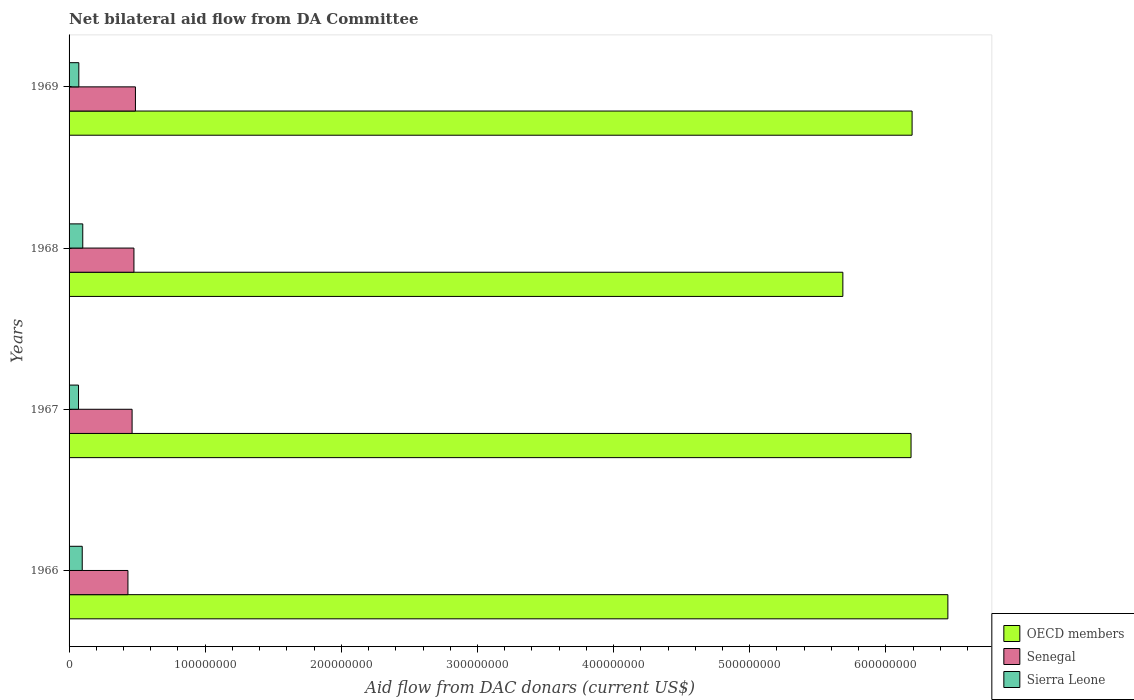Are the number of bars per tick equal to the number of legend labels?
Your answer should be compact. Yes. Are the number of bars on each tick of the Y-axis equal?
Provide a succinct answer. Yes. What is the label of the 3rd group of bars from the top?
Offer a very short reply. 1967. What is the aid flow in in OECD members in 1967?
Give a very brief answer. 6.18e+08. Across all years, what is the maximum aid flow in in Senegal?
Your answer should be compact. 4.88e+07. Across all years, what is the minimum aid flow in in Senegal?
Keep it short and to the point. 4.32e+07. In which year was the aid flow in in Sierra Leone maximum?
Offer a very short reply. 1968. In which year was the aid flow in in OECD members minimum?
Offer a terse response. 1968. What is the total aid flow in in Senegal in the graph?
Give a very brief answer. 1.86e+08. What is the difference between the aid flow in in OECD members in 1966 and that in 1967?
Your answer should be compact. 2.71e+07. What is the difference between the aid flow in in Senegal in 1969 and the aid flow in in OECD members in 1968?
Your answer should be very brief. -5.20e+08. What is the average aid flow in in Sierra Leone per year?
Provide a short and direct response. 8.46e+06. In the year 1968, what is the difference between the aid flow in in Sierra Leone and aid flow in in Senegal?
Keep it short and to the point. -3.76e+07. In how many years, is the aid flow in in OECD members greater than 440000000 US$?
Ensure brevity in your answer.  4. What is the ratio of the aid flow in in Senegal in 1967 to that in 1968?
Provide a succinct answer. 0.97. What is the difference between the highest and the second highest aid flow in in Sierra Leone?
Keep it short and to the point. 3.90e+05. What is the difference between the highest and the lowest aid flow in in Senegal?
Provide a succinct answer. 5.51e+06. Is the sum of the aid flow in in Senegal in 1967 and 1969 greater than the maximum aid flow in in Sierra Leone across all years?
Make the answer very short. Yes. What does the 3rd bar from the top in 1968 represents?
Ensure brevity in your answer.  OECD members. What does the 2nd bar from the bottom in 1967 represents?
Ensure brevity in your answer.  Senegal. Is it the case that in every year, the sum of the aid flow in in OECD members and aid flow in in Sierra Leone is greater than the aid flow in in Senegal?
Keep it short and to the point. Yes. How many bars are there?
Give a very brief answer. 12. How many years are there in the graph?
Provide a succinct answer. 4. What is the difference between two consecutive major ticks on the X-axis?
Offer a very short reply. 1.00e+08. Does the graph contain any zero values?
Your response must be concise. No. Where does the legend appear in the graph?
Offer a terse response. Bottom right. How many legend labels are there?
Provide a short and direct response. 3. How are the legend labels stacked?
Provide a short and direct response. Vertical. What is the title of the graph?
Offer a terse response. Net bilateral aid flow from DA Committee. What is the label or title of the X-axis?
Keep it short and to the point. Aid flow from DAC donars (current US$). What is the label or title of the Y-axis?
Provide a short and direct response. Years. What is the Aid flow from DAC donars (current US$) in OECD members in 1966?
Your answer should be very brief. 6.46e+08. What is the Aid flow from DAC donars (current US$) of Senegal in 1966?
Your answer should be compact. 4.32e+07. What is the Aid flow from DAC donars (current US$) in Sierra Leone in 1966?
Keep it short and to the point. 9.67e+06. What is the Aid flow from DAC donars (current US$) in OECD members in 1967?
Offer a terse response. 6.18e+08. What is the Aid flow from DAC donars (current US$) in Senegal in 1967?
Provide a short and direct response. 4.63e+07. What is the Aid flow from DAC donars (current US$) of Sierra Leone in 1967?
Offer a terse response. 6.94e+06. What is the Aid flow from DAC donars (current US$) in OECD members in 1968?
Ensure brevity in your answer.  5.68e+08. What is the Aid flow from DAC donars (current US$) in Senegal in 1968?
Offer a very short reply. 4.76e+07. What is the Aid flow from DAC donars (current US$) of Sierra Leone in 1968?
Your answer should be very brief. 1.01e+07. What is the Aid flow from DAC donars (current US$) of OECD members in 1969?
Your answer should be very brief. 6.19e+08. What is the Aid flow from DAC donars (current US$) of Senegal in 1969?
Provide a succinct answer. 4.88e+07. What is the Aid flow from DAC donars (current US$) of Sierra Leone in 1969?
Offer a very short reply. 7.17e+06. Across all years, what is the maximum Aid flow from DAC donars (current US$) of OECD members?
Provide a short and direct response. 6.46e+08. Across all years, what is the maximum Aid flow from DAC donars (current US$) of Senegal?
Make the answer very short. 4.88e+07. Across all years, what is the maximum Aid flow from DAC donars (current US$) in Sierra Leone?
Ensure brevity in your answer.  1.01e+07. Across all years, what is the minimum Aid flow from DAC donars (current US$) of OECD members?
Give a very brief answer. 5.68e+08. Across all years, what is the minimum Aid flow from DAC donars (current US$) of Senegal?
Give a very brief answer. 4.32e+07. Across all years, what is the minimum Aid flow from DAC donars (current US$) of Sierra Leone?
Offer a terse response. 6.94e+06. What is the total Aid flow from DAC donars (current US$) of OECD members in the graph?
Make the answer very short. 2.45e+09. What is the total Aid flow from DAC donars (current US$) of Senegal in the graph?
Keep it short and to the point. 1.86e+08. What is the total Aid flow from DAC donars (current US$) of Sierra Leone in the graph?
Keep it short and to the point. 3.38e+07. What is the difference between the Aid flow from DAC donars (current US$) in OECD members in 1966 and that in 1967?
Make the answer very short. 2.71e+07. What is the difference between the Aid flow from DAC donars (current US$) of Senegal in 1966 and that in 1967?
Give a very brief answer. -3.05e+06. What is the difference between the Aid flow from DAC donars (current US$) of Sierra Leone in 1966 and that in 1967?
Offer a terse response. 2.73e+06. What is the difference between the Aid flow from DAC donars (current US$) of OECD members in 1966 and that in 1968?
Provide a succinct answer. 7.71e+07. What is the difference between the Aid flow from DAC donars (current US$) in Senegal in 1966 and that in 1968?
Provide a succinct answer. -4.41e+06. What is the difference between the Aid flow from DAC donars (current US$) in Sierra Leone in 1966 and that in 1968?
Ensure brevity in your answer.  -3.90e+05. What is the difference between the Aid flow from DAC donars (current US$) of OECD members in 1966 and that in 1969?
Your answer should be compact. 2.63e+07. What is the difference between the Aid flow from DAC donars (current US$) in Senegal in 1966 and that in 1969?
Your answer should be very brief. -5.51e+06. What is the difference between the Aid flow from DAC donars (current US$) in Sierra Leone in 1966 and that in 1969?
Give a very brief answer. 2.50e+06. What is the difference between the Aid flow from DAC donars (current US$) in OECD members in 1967 and that in 1968?
Give a very brief answer. 5.01e+07. What is the difference between the Aid flow from DAC donars (current US$) of Senegal in 1967 and that in 1968?
Your response must be concise. -1.36e+06. What is the difference between the Aid flow from DAC donars (current US$) in Sierra Leone in 1967 and that in 1968?
Provide a short and direct response. -3.12e+06. What is the difference between the Aid flow from DAC donars (current US$) of OECD members in 1967 and that in 1969?
Offer a very short reply. -7.70e+05. What is the difference between the Aid flow from DAC donars (current US$) in Senegal in 1967 and that in 1969?
Offer a very short reply. -2.46e+06. What is the difference between the Aid flow from DAC donars (current US$) of OECD members in 1968 and that in 1969?
Your response must be concise. -5.08e+07. What is the difference between the Aid flow from DAC donars (current US$) in Senegal in 1968 and that in 1969?
Make the answer very short. -1.10e+06. What is the difference between the Aid flow from DAC donars (current US$) of Sierra Leone in 1968 and that in 1969?
Provide a succinct answer. 2.89e+06. What is the difference between the Aid flow from DAC donars (current US$) of OECD members in 1966 and the Aid flow from DAC donars (current US$) of Senegal in 1967?
Keep it short and to the point. 5.99e+08. What is the difference between the Aid flow from DAC donars (current US$) of OECD members in 1966 and the Aid flow from DAC donars (current US$) of Sierra Leone in 1967?
Your response must be concise. 6.39e+08. What is the difference between the Aid flow from DAC donars (current US$) in Senegal in 1966 and the Aid flow from DAC donars (current US$) in Sierra Leone in 1967?
Ensure brevity in your answer.  3.63e+07. What is the difference between the Aid flow from DAC donars (current US$) in OECD members in 1966 and the Aid flow from DAC donars (current US$) in Senegal in 1968?
Your answer should be compact. 5.98e+08. What is the difference between the Aid flow from DAC donars (current US$) of OECD members in 1966 and the Aid flow from DAC donars (current US$) of Sierra Leone in 1968?
Give a very brief answer. 6.35e+08. What is the difference between the Aid flow from DAC donars (current US$) of Senegal in 1966 and the Aid flow from DAC donars (current US$) of Sierra Leone in 1968?
Offer a terse response. 3.32e+07. What is the difference between the Aid flow from DAC donars (current US$) of OECD members in 1966 and the Aid flow from DAC donars (current US$) of Senegal in 1969?
Keep it short and to the point. 5.97e+08. What is the difference between the Aid flow from DAC donars (current US$) of OECD members in 1966 and the Aid flow from DAC donars (current US$) of Sierra Leone in 1969?
Offer a terse response. 6.38e+08. What is the difference between the Aid flow from DAC donars (current US$) in Senegal in 1966 and the Aid flow from DAC donars (current US$) in Sierra Leone in 1969?
Ensure brevity in your answer.  3.61e+07. What is the difference between the Aid flow from DAC donars (current US$) in OECD members in 1967 and the Aid flow from DAC donars (current US$) in Senegal in 1968?
Make the answer very short. 5.71e+08. What is the difference between the Aid flow from DAC donars (current US$) of OECD members in 1967 and the Aid flow from DAC donars (current US$) of Sierra Leone in 1968?
Offer a very short reply. 6.08e+08. What is the difference between the Aid flow from DAC donars (current US$) in Senegal in 1967 and the Aid flow from DAC donars (current US$) in Sierra Leone in 1968?
Make the answer very short. 3.62e+07. What is the difference between the Aid flow from DAC donars (current US$) in OECD members in 1967 and the Aid flow from DAC donars (current US$) in Senegal in 1969?
Your answer should be very brief. 5.70e+08. What is the difference between the Aid flow from DAC donars (current US$) of OECD members in 1967 and the Aid flow from DAC donars (current US$) of Sierra Leone in 1969?
Ensure brevity in your answer.  6.11e+08. What is the difference between the Aid flow from DAC donars (current US$) of Senegal in 1967 and the Aid flow from DAC donars (current US$) of Sierra Leone in 1969?
Your answer should be very brief. 3.91e+07. What is the difference between the Aid flow from DAC donars (current US$) of OECD members in 1968 and the Aid flow from DAC donars (current US$) of Senegal in 1969?
Your answer should be compact. 5.20e+08. What is the difference between the Aid flow from DAC donars (current US$) of OECD members in 1968 and the Aid flow from DAC donars (current US$) of Sierra Leone in 1969?
Give a very brief answer. 5.61e+08. What is the difference between the Aid flow from DAC donars (current US$) in Senegal in 1968 and the Aid flow from DAC donars (current US$) in Sierra Leone in 1969?
Keep it short and to the point. 4.05e+07. What is the average Aid flow from DAC donars (current US$) in OECD members per year?
Offer a terse response. 6.13e+08. What is the average Aid flow from DAC donars (current US$) of Senegal per year?
Make the answer very short. 4.65e+07. What is the average Aid flow from DAC donars (current US$) in Sierra Leone per year?
Your answer should be very brief. 8.46e+06. In the year 1966, what is the difference between the Aid flow from DAC donars (current US$) of OECD members and Aid flow from DAC donars (current US$) of Senegal?
Your answer should be very brief. 6.02e+08. In the year 1966, what is the difference between the Aid flow from DAC donars (current US$) in OECD members and Aid flow from DAC donars (current US$) in Sierra Leone?
Give a very brief answer. 6.36e+08. In the year 1966, what is the difference between the Aid flow from DAC donars (current US$) of Senegal and Aid flow from DAC donars (current US$) of Sierra Leone?
Offer a very short reply. 3.36e+07. In the year 1967, what is the difference between the Aid flow from DAC donars (current US$) of OECD members and Aid flow from DAC donars (current US$) of Senegal?
Keep it short and to the point. 5.72e+08. In the year 1967, what is the difference between the Aid flow from DAC donars (current US$) in OECD members and Aid flow from DAC donars (current US$) in Sierra Leone?
Give a very brief answer. 6.12e+08. In the year 1967, what is the difference between the Aid flow from DAC donars (current US$) of Senegal and Aid flow from DAC donars (current US$) of Sierra Leone?
Offer a terse response. 3.94e+07. In the year 1968, what is the difference between the Aid flow from DAC donars (current US$) of OECD members and Aid flow from DAC donars (current US$) of Senegal?
Ensure brevity in your answer.  5.21e+08. In the year 1968, what is the difference between the Aid flow from DAC donars (current US$) in OECD members and Aid flow from DAC donars (current US$) in Sierra Leone?
Your answer should be very brief. 5.58e+08. In the year 1968, what is the difference between the Aid flow from DAC donars (current US$) of Senegal and Aid flow from DAC donars (current US$) of Sierra Leone?
Keep it short and to the point. 3.76e+07. In the year 1969, what is the difference between the Aid flow from DAC donars (current US$) of OECD members and Aid flow from DAC donars (current US$) of Senegal?
Give a very brief answer. 5.70e+08. In the year 1969, what is the difference between the Aid flow from DAC donars (current US$) in OECD members and Aid flow from DAC donars (current US$) in Sierra Leone?
Provide a short and direct response. 6.12e+08. In the year 1969, what is the difference between the Aid flow from DAC donars (current US$) of Senegal and Aid flow from DAC donars (current US$) of Sierra Leone?
Make the answer very short. 4.16e+07. What is the ratio of the Aid flow from DAC donars (current US$) in OECD members in 1966 to that in 1967?
Ensure brevity in your answer.  1.04. What is the ratio of the Aid flow from DAC donars (current US$) of Senegal in 1966 to that in 1967?
Give a very brief answer. 0.93. What is the ratio of the Aid flow from DAC donars (current US$) in Sierra Leone in 1966 to that in 1967?
Give a very brief answer. 1.39. What is the ratio of the Aid flow from DAC donars (current US$) in OECD members in 1966 to that in 1968?
Provide a succinct answer. 1.14. What is the ratio of the Aid flow from DAC donars (current US$) in Senegal in 1966 to that in 1968?
Provide a short and direct response. 0.91. What is the ratio of the Aid flow from DAC donars (current US$) of Sierra Leone in 1966 to that in 1968?
Offer a very short reply. 0.96. What is the ratio of the Aid flow from DAC donars (current US$) in OECD members in 1966 to that in 1969?
Make the answer very short. 1.04. What is the ratio of the Aid flow from DAC donars (current US$) of Senegal in 1966 to that in 1969?
Provide a short and direct response. 0.89. What is the ratio of the Aid flow from DAC donars (current US$) of Sierra Leone in 1966 to that in 1969?
Your answer should be very brief. 1.35. What is the ratio of the Aid flow from DAC donars (current US$) of OECD members in 1967 to that in 1968?
Keep it short and to the point. 1.09. What is the ratio of the Aid flow from DAC donars (current US$) of Senegal in 1967 to that in 1968?
Your answer should be very brief. 0.97. What is the ratio of the Aid flow from DAC donars (current US$) in Sierra Leone in 1967 to that in 1968?
Your answer should be very brief. 0.69. What is the ratio of the Aid flow from DAC donars (current US$) of OECD members in 1967 to that in 1969?
Keep it short and to the point. 1. What is the ratio of the Aid flow from DAC donars (current US$) of Senegal in 1967 to that in 1969?
Provide a short and direct response. 0.95. What is the ratio of the Aid flow from DAC donars (current US$) of Sierra Leone in 1967 to that in 1969?
Give a very brief answer. 0.97. What is the ratio of the Aid flow from DAC donars (current US$) in OECD members in 1968 to that in 1969?
Offer a very short reply. 0.92. What is the ratio of the Aid flow from DAC donars (current US$) of Senegal in 1968 to that in 1969?
Your response must be concise. 0.98. What is the ratio of the Aid flow from DAC donars (current US$) of Sierra Leone in 1968 to that in 1969?
Provide a succinct answer. 1.4. What is the difference between the highest and the second highest Aid flow from DAC donars (current US$) of OECD members?
Your answer should be compact. 2.63e+07. What is the difference between the highest and the second highest Aid flow from DAC donars (current US$) of Senegal?
Keep it short and to the point. 1.10e+06. What is the difference between the highest and the lowest Aid flow from DAC donars (current US$) of OECD members?
Offer a very short reply. 7.71e+07. What is the difference between the highest and the lowest Aid flow from DAC donars (current US$) of Senegal?
Ensure brevity in your answer.  5.51e+06. What is the difference between the highest and the lowest Aid flow from DAC donars (current US$) of Sierra Leone?
Offer a terse response. 3.12e+06. 